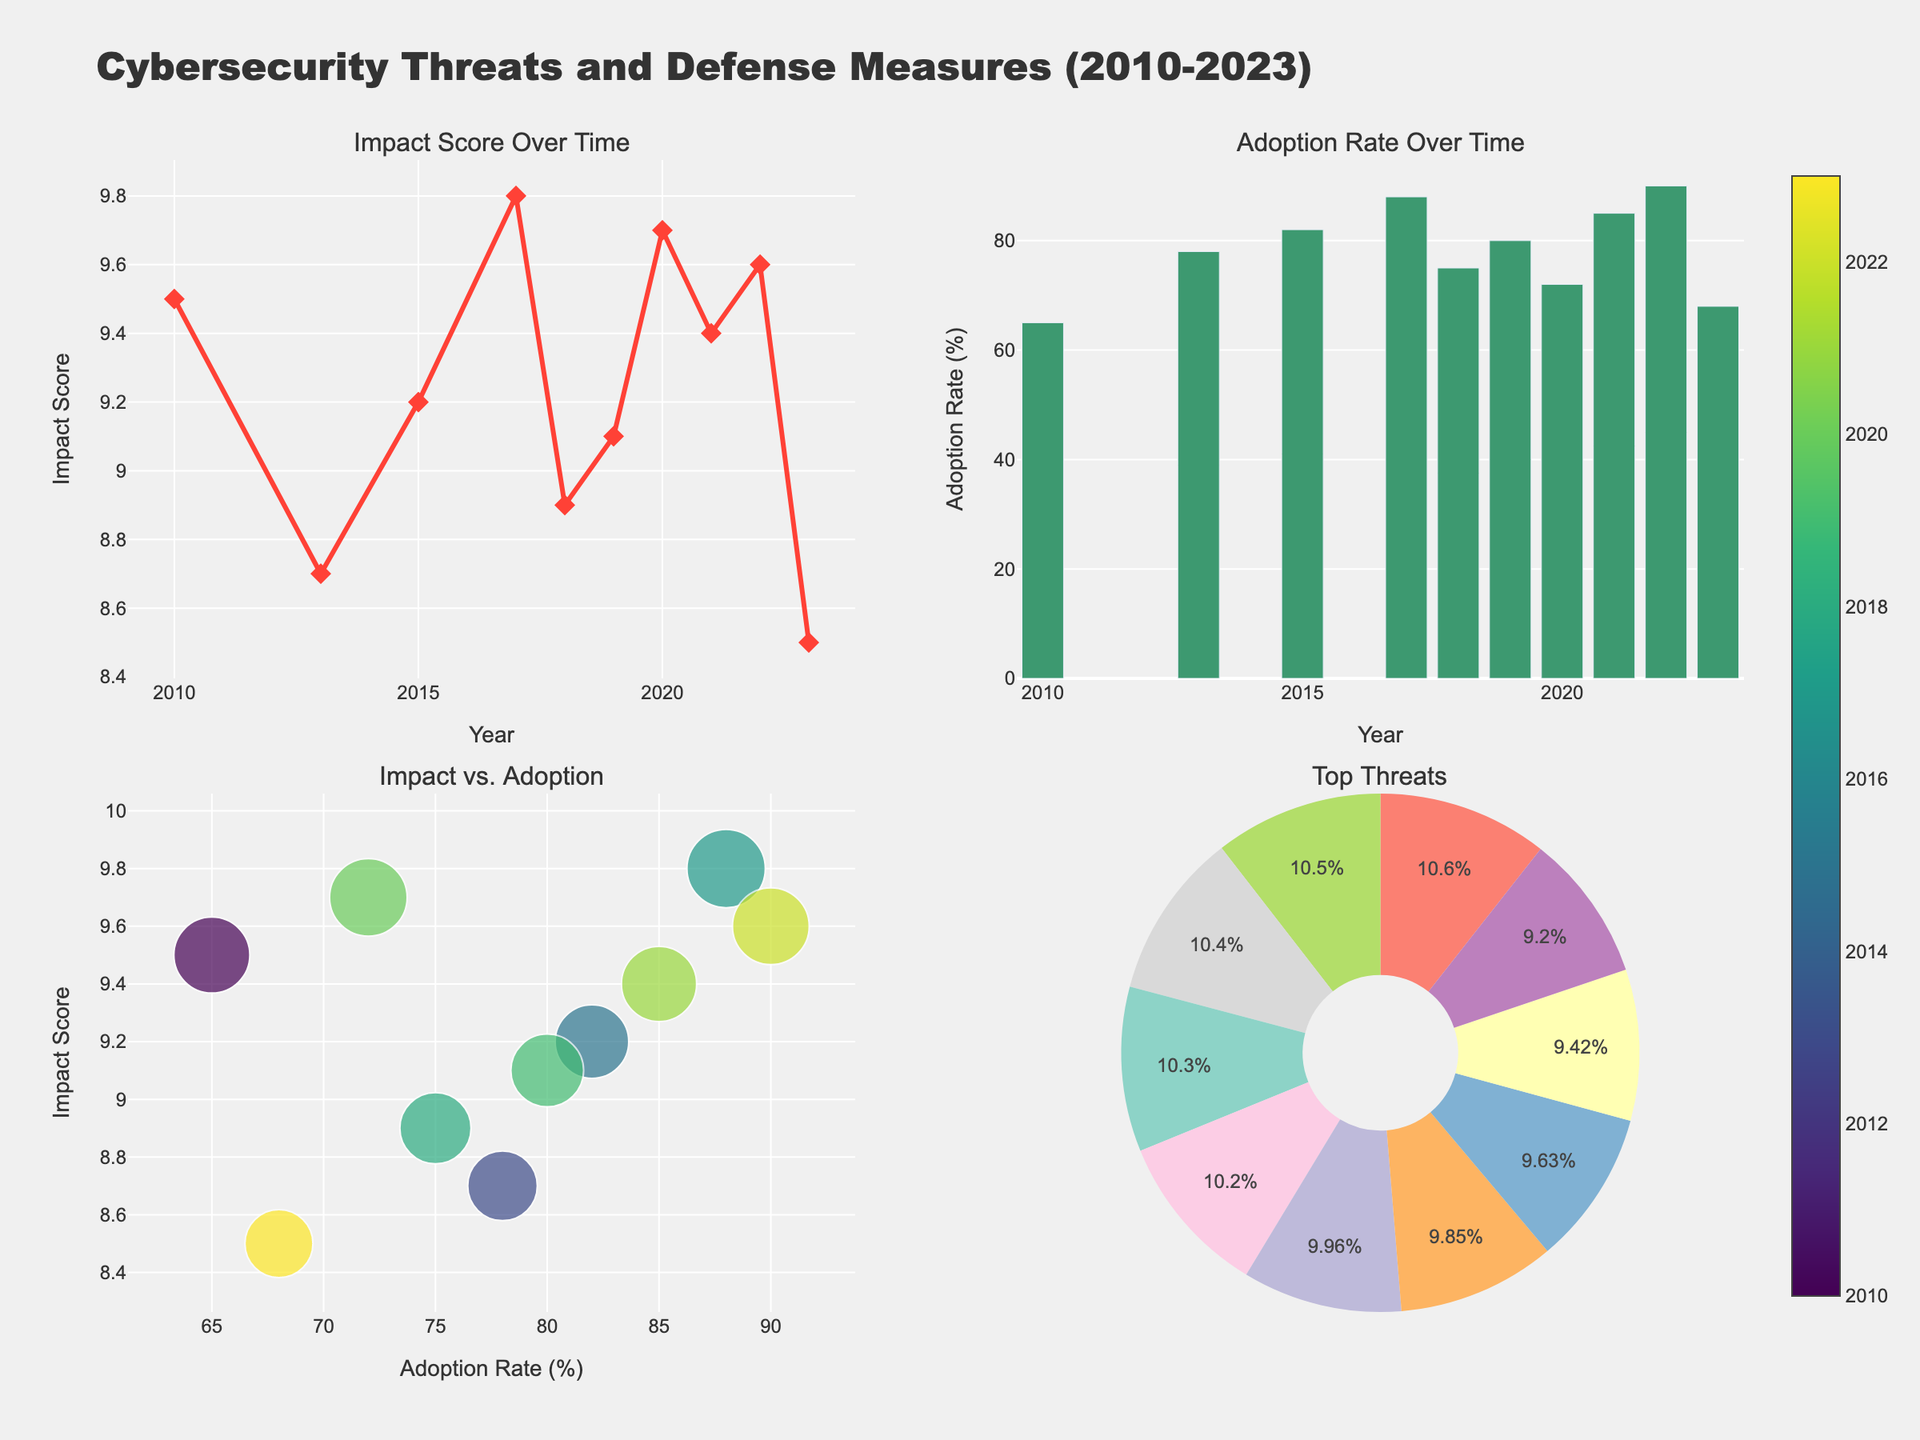What is the title of the plot? The title is displayed at the top of the figure in large, bold text. It provides a summary of the overall content and context of the figure.
Answer: Cybersecurity Threats and Defense Measures (2010-2023) Which threat had the highest impact score? The scatter plot in the top-left subplot shows the impact scores over time, and the highest point represents the highest impact score.
Answer: WannaCry ransomware What is the adoption rate for PCI DSS compliance? The bar chart in the top-right subplot lists the adoption rates over time, and specific values can be read directly from the bars corresponding to each year.
Answer: 78% Which years saw an increase in the adoption rate of defense measures? To determine this, we need to look at the bar heights in the top-right subplot and identify which years have increasing heights compared to the previous year.
Answer: 2015, 2017, 2021, 2022 How do the impact scores of Stuxnet and the SolarWinds supply chain attack compare? The scatter plot in the top-left subplot shows individual impact scores over time. Comparing the scores of these two specific threats will answer the question.
Answer: Stuxnet: 9.5, SolarWinds: 9.7 In which year was Cloud Security Solutions adopted and what was its adoption rate? The bar chart in the top-right subplot gives adoption rates for different years, and the defense measure can be linked to its adoption year through the data labels.
Answer: 2019, 80% What is the trend of the adoption rate over the given years? To identify the trend, we need to visually inspect the bar chart in the top-right subplot and note whether the bars generally increase, decrease, or fluctuate.
Answer: Generally increasing Which defense measure had the highest adoption rate and what was that rate? The bar chart in the top-right subplot shows various adoption rates, and we need to find the highest bar and check its value.
Answer: Vulnerability management, 90% What is the relationship between the adoption rate and the impact score? The scatter plot in the bottom-left subplot shows the correlation between adoption rate and impact score. We can observe the trend and overall distribution of points to determine the relationship.
Answer: Generally positive correlation Which threat had a lower impact score than the Log4j vulnerability but higher than the ChatGPT prompt injection? Using the impact scores displayed on the scatter plots, we need to identify a threat that falls between these two specific impact scores.
Answer: Marriott data breach 